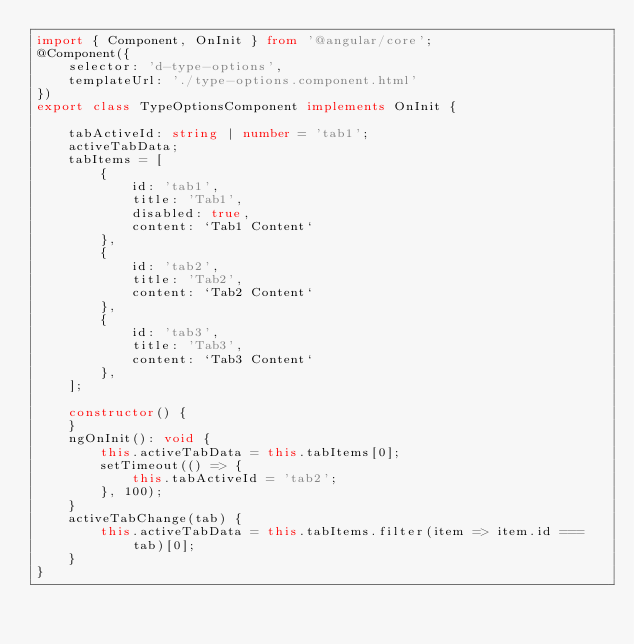<code> <loc_0><loc_0><loc_500><loc_500><_TypeScript_>import { Component, OnInit } from '@angular/core';
@Component({
    selector: 'd-type-options',
    templateUrl: './type-options.component.html'
})
export class TypeOptionsComponent implements OnInit {

    tabActiveId: string | number = 'tab1';
    activeTabData;
    tabItems = [
        {
            id: 'tab1',
            title: 'Tab1',
            disabled: true,
            content: `Tab1 Content`
        },
        {
            id: 'tab2',
            title: 'Tab2',
            content: `Tab2 Content`
        },
        {
            id: 'tab3',
            title: 'Tab3',
            content: `Tab3 Content`
        },
    ];

    constructor() {
    }
    ngOnInit(): void {
        this.activeTabData = this.tabItems[0];
        setTimeout(() => {
            this.tabActiveId = 'tab2';
        }, 100);
    }
    activeTabChange(tab) {
        this.activeTabData = this.tabItems.filter(item => item.id === tab)[0];
    }
}
</code> 